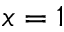Convert formula to latex. <formula><loc_0><loc_0><loc_500><loc_500>x = 1</formula> 